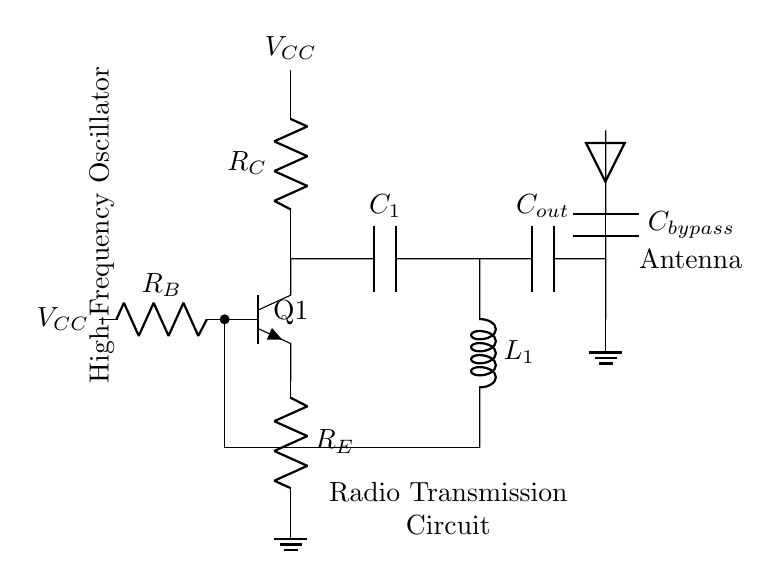What type of transistor is used in this circuit? The circuit diagram shows an npn transistor, indicated by the label npn next to the transistor symbol Q1.
Answer: npn What are the components forming the feedback network? The feedback network consists of a capacitor denoted as C1 and an inductor labeled L1, which are connected between the collector of Q1 and the base of Q1.
Answer: C1 and L1 What is the role of capacitor C_bypass in the circuit? The capacitor C_bypass is used for power supply decoupling, ensuring stability and reducing noise from the power supply by diverting high-frequency variations to ground.
Answer: Power supply decoupling How does the oscillator maintain its operation? The oscillator maintains operation through positive feedback provided by the feedback network (C1 and L1), allowing continuous oscillation when the transistor Q1 is biased properly.
Answer: Positive feedback What is the likely purpose of the output capacitor C_out? The output capacitor C_out couples the high-frequency signals to the antenna while blocking DC components, allowing only AC signals to pass through for wireless transmission.
Answer: Coupling high-frequency signals What voltage is indicated at the power supply points? The voltage is V_CC, which is marked at both the base and collector of the npn transistor Q1, indicating that these points share the same power supply voltage.
Answer: V_CC What is the significance of the antenna in this circuit? The antenna is crucial for transmitting the oscillated signal wirelessly; it converts the output signal into electromagnetic waves for communication.
Answer: Wireless signal transmission 